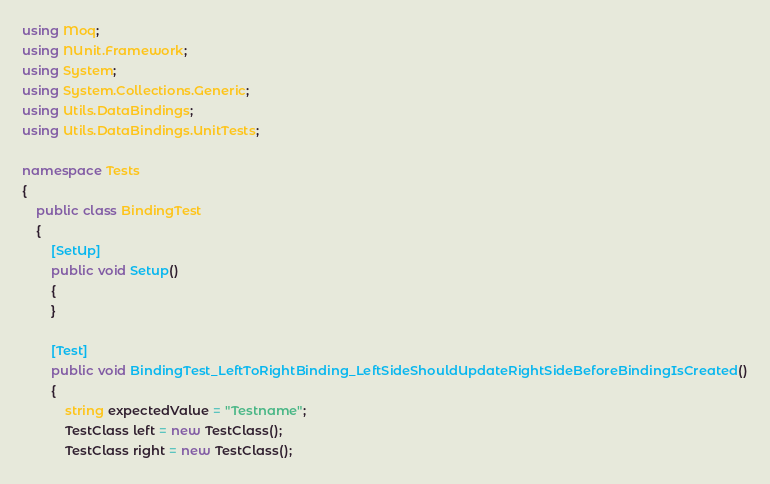Convert code to text. <code><loc_0><loc_0><loc_500><loc_500><_C#_>using Moq;
using NUnit.Framework;
using System;
using System.Collections.Generic;
using Utils.DataBindings;
using Utils.DataBindings.UnitTests;

namespace Tests
{
    public class BindingTest
    {
        [SetUp]
        public void Setup()
        {
        }

        [Test]
        public void BindingTest_LeftToRightBinding_LeftSideShouldUpdateRightSideBeforeBindingIsCreated()
        {
            string expectedValue = "Testname";
            TestClass left = new TestClass();
            TestClass right = new TestClass();</code> 